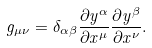Convert formula to latex. <formula><loc_0><loc_0><loc_500><loc_500>g _ { \mu \nu } = \delta _ { \alpha \beta } \frac { \partial y ^ { \alpha } } { \partial x ^ { \mu } } \frac { \partial y ^ { \beta } } { \partial x ^ { \nu } } .</formula> 